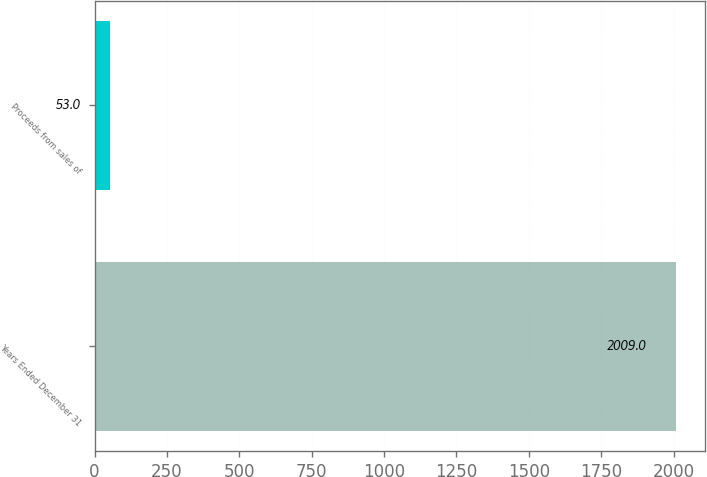Convert chart. <chart><loc_0><loc_0><loc_500><loc_500><bar_chart><fcel>Years Ended December 31<fcel>Proceeds from sales of<nl><fcel>2009<fcel>53<nl></chart> 